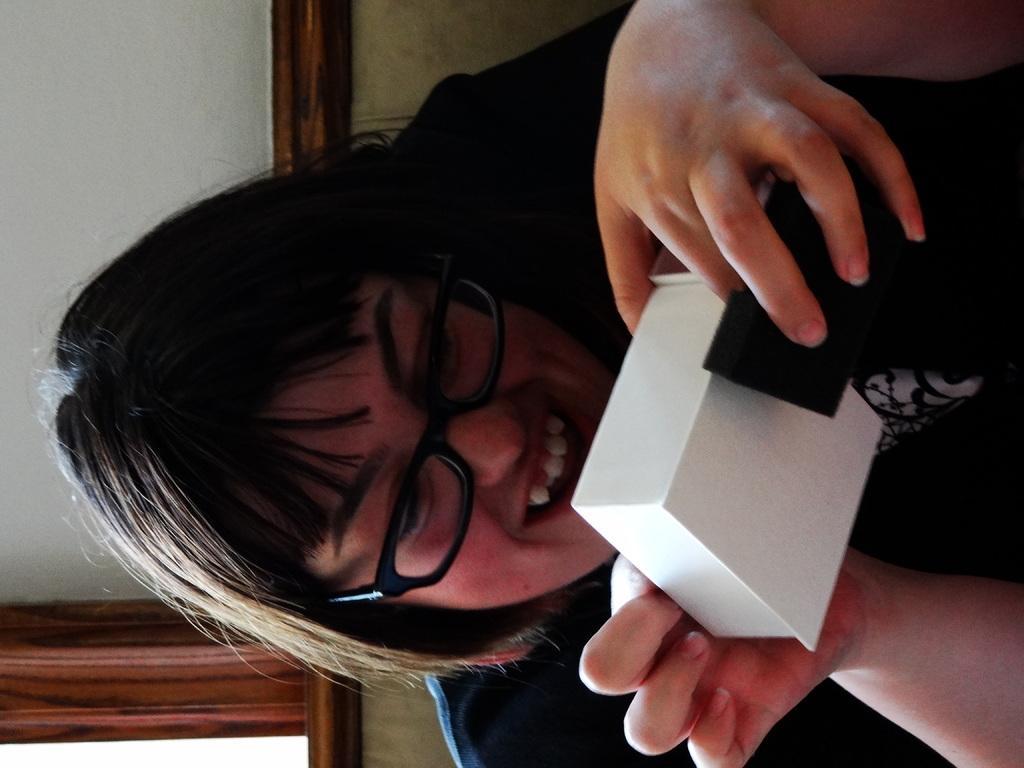Can you describe this image briefly? At the bottom of the picture, we see the girl in black T-shirt is sitting on the chair. She is holding a white box in her hands. She is wearing spectacles. Behind her, we see a wall in white color. Beside that, there is a curtain in brown color. This picture is clicked inside the room. 